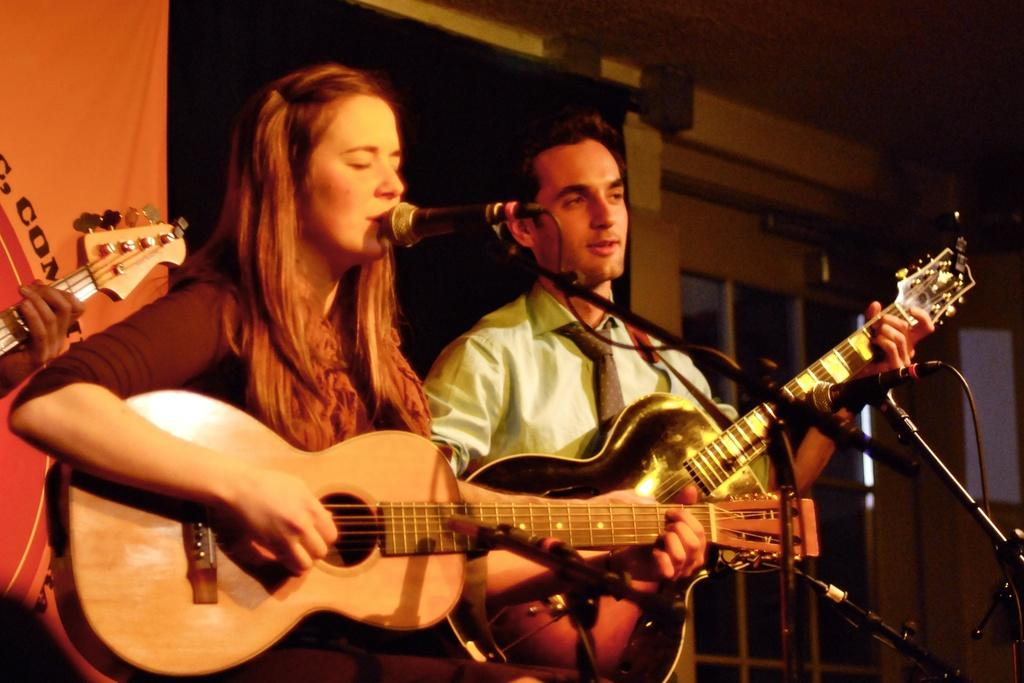Who are the people in the image? There is a man and a woman in the image. What are the man and woman holding in the image? The man and woman are holding guitars. What is the woman doing in the image? The woman is singing a song. What equipment is set up in front of them? There are microphones with mic stands in front of them. What can be seen in the background of the image? There is a banner in the background. What architectural feature is visible in the image? There are windows visible in the image. What type of ice can be seen melting on the tray in the image? There is no ice or tray present in the image. What is the woman using to brush her teeth in the image? There is no toothbrush or toothbrushing activity depicted in the image. 